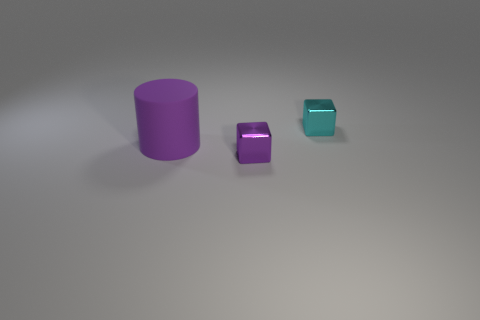Is there a large matte cylinder that has the same color as the big object? Yes, the large cylinder on the left has the same matte finish and color as the larger object. 